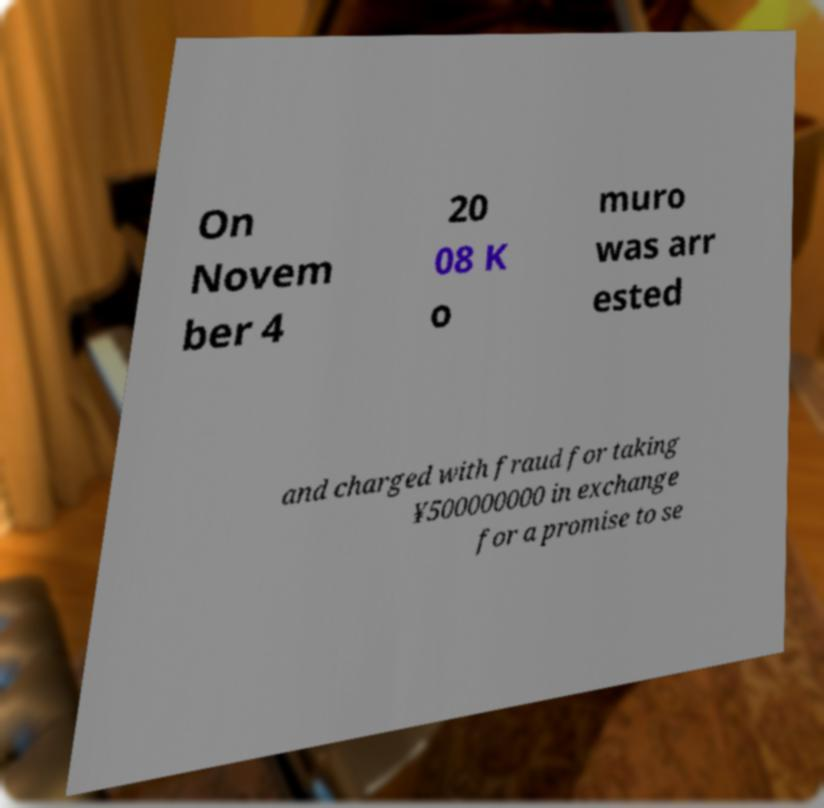For documentation purposes, I need the text within this image transcribed. Could you provide that? On Novem ber 4 20 08 K o muro was arr ested and charged with fraud for taking ¥500000000 in exchange for a promise to se 